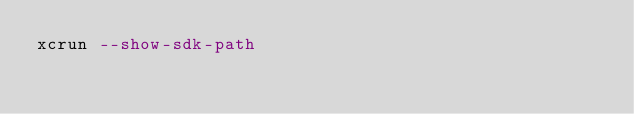<code> <loc_0><loc_0><loc_500><loc_500><_SQL_>xcrun --show-sdk-path
</code> 